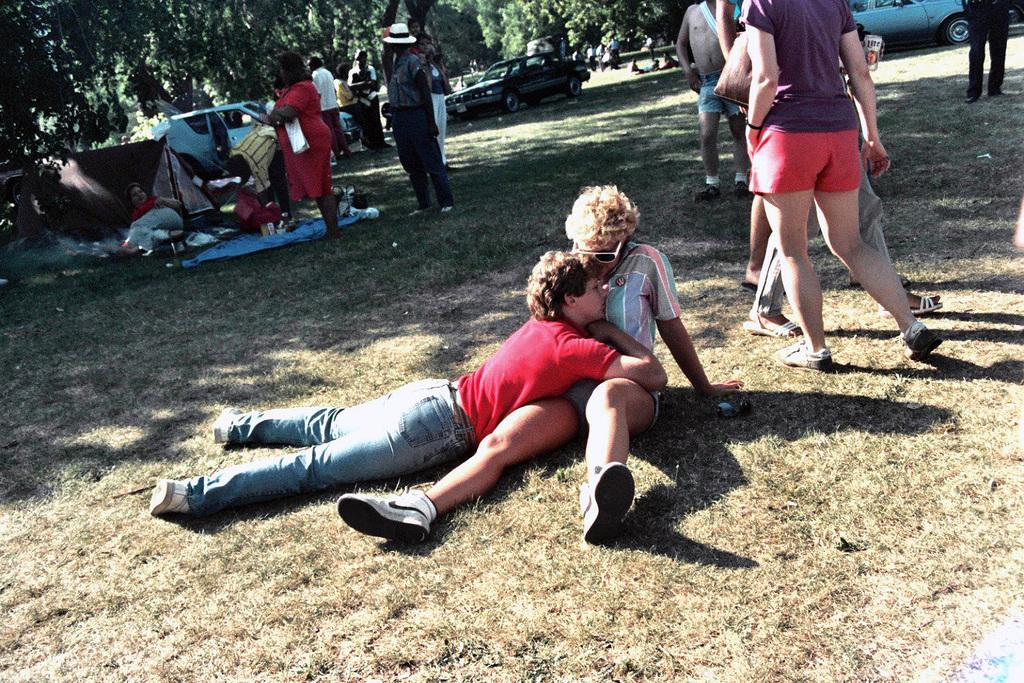What can be seen in the foreground of the picture? There are people and grass in the foreground of the picture. What is present in the middle of the picture? There are people, trees, tents, cars, grass, and a mat in the middle of the picture. What is visible in the background of the picture? There are trees in the background of the picture. What type of sack can be seen being used for treatment in the image? There is no sack or treatment present in the image. What flavor of cake is being served to the people in the middle of the picture? There is no cake present in the image. 